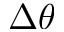<formula> <loc_0><loc_0><loc_500><loc_500>\Delta \theta</formula> 